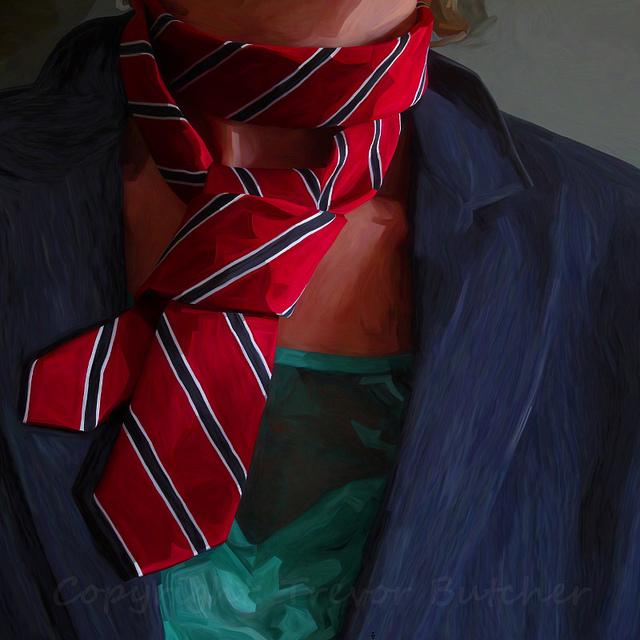Has the tie been tied in the normal fashion?
Give a very brief answer. No. What color is the tie?
Quick response, please. Red. Why is the person putting on a tie?
Be succinct. Playing. Does the tie have stripes?
Give a very brief answer. Yes. Is that what you'd call a bold pattern?
Be succinct. Yes. Is this a painting or a photo?
Keep it brief. Painting. What type of pattern is the red fabric?
Write a very short answer. Striped. 